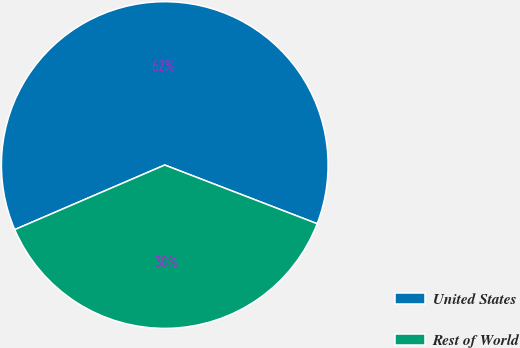Convert chart. <chart><loc_0><loc_0><loc_500><loc_500><pie_chart><fcel>United States<fcel>Rest of World<nl><fcel>62.32%<fcel>37.68%<nl></chart> 